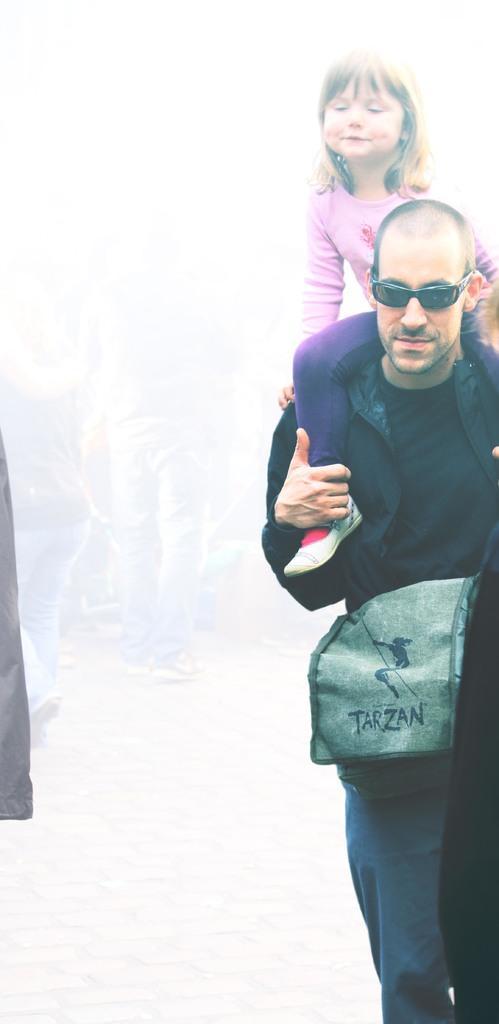Please provide a concise description of this image. Here in this picture we can see a person walking on the road and we can see goggles and bag on him and we can see a child sitting on him over there. 